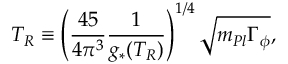<formula> <loc_0><loc_0><loc_500><loc_500>T _ { R } \equiv \left ( \frac { 4 5 } { 4 \pi ^ { 3 } } \frac { 1 } { g _ { * } ( T _ { R } ) } \right ) ^ { 1 / 4 } \sqrt { m _ { P l } \Gamma _ { \phi } } ,</formula> 